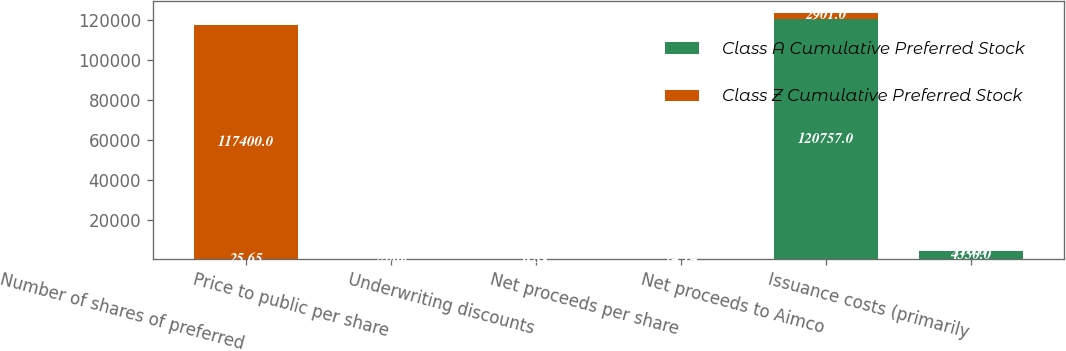<chart> <loc_0><loc_0><loc_500><loc_500><stacked_bar_chart><ecel><fcel>Number of shares of preferred<fcel>Price to public per share<fcel>Underwriting discounts<fcel>Net proceeds per share<fcel>Net proceeds to Aimco<fcel>Issuance costs (primarily<nl><fcel>Class A Cumulative Preferred Stock<fcel>25.65<fcel>25<fcel>0.85<fcel>24.15<fcel>120757<fcel>4350<nl><fcel>Class Z Cumulative Preferred Stock<fcel>117400<fcel>25.65<fcel>0.51<fcel>25.14<fcel>2901<fcel>110<nl></chart> 